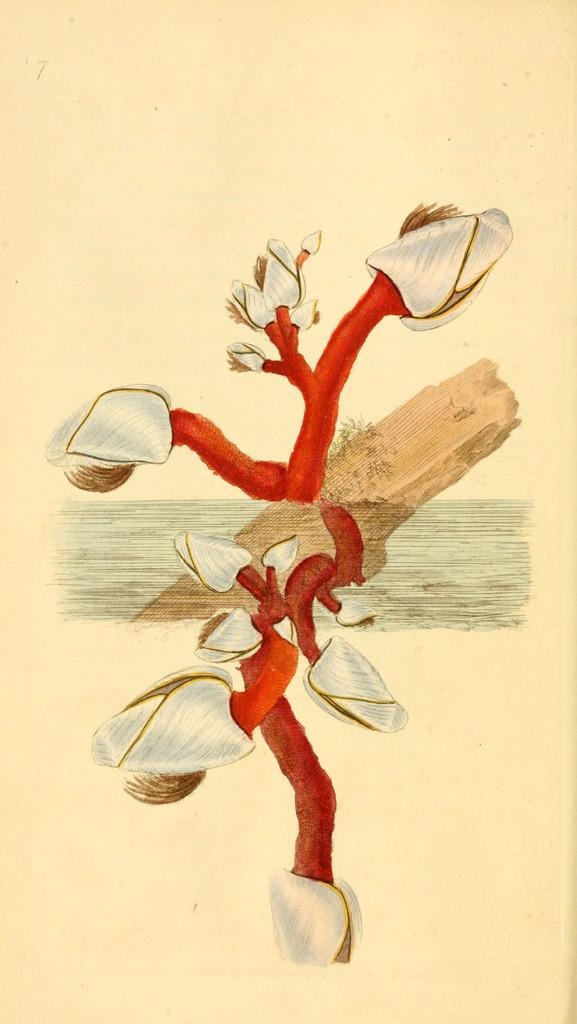What is the main subject of the picture? The main subject of the picture is a sketch of flowers. What colors are used in the sketch? The sketch includes white and red colors. What is the color of the background in the image? The background of the image is in cream color. What type of plastic cart can be seen in the image? There is no plastic cart present in the image; it features a sketch of flowers with a cream-colored background. 